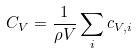<formula> <loc_0><loc_0><loc_500><loc_500>C _ { V } = \frac { 1 } { \rho V } \sum _ { i } c _ { V , i }</formula> 